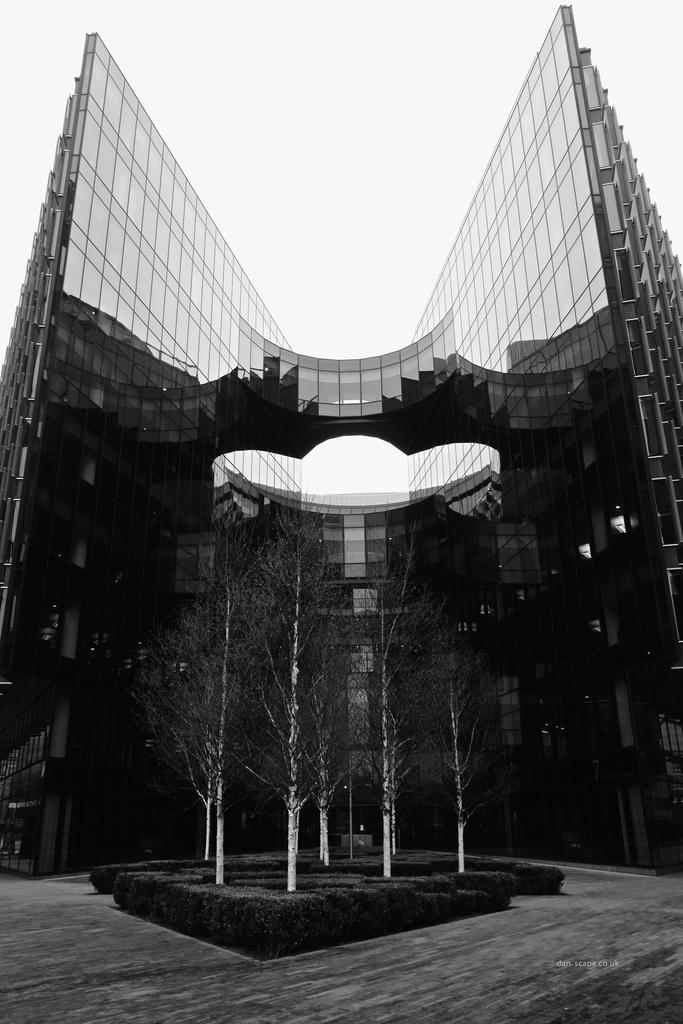What structures are visible in the image? There are buildings in the image. What type of vegetation is present in the image? There are trees in the image. What is visible at the top of the image? The sky is visible at the top of the image. What type of leather can be seen on the zebra in the image? There is no zebra present in the image, and therefore no leather can be observed. What type of knife is being used to cut the trees in the image? There is no knife or tree-cutting activity depicted in the image. 